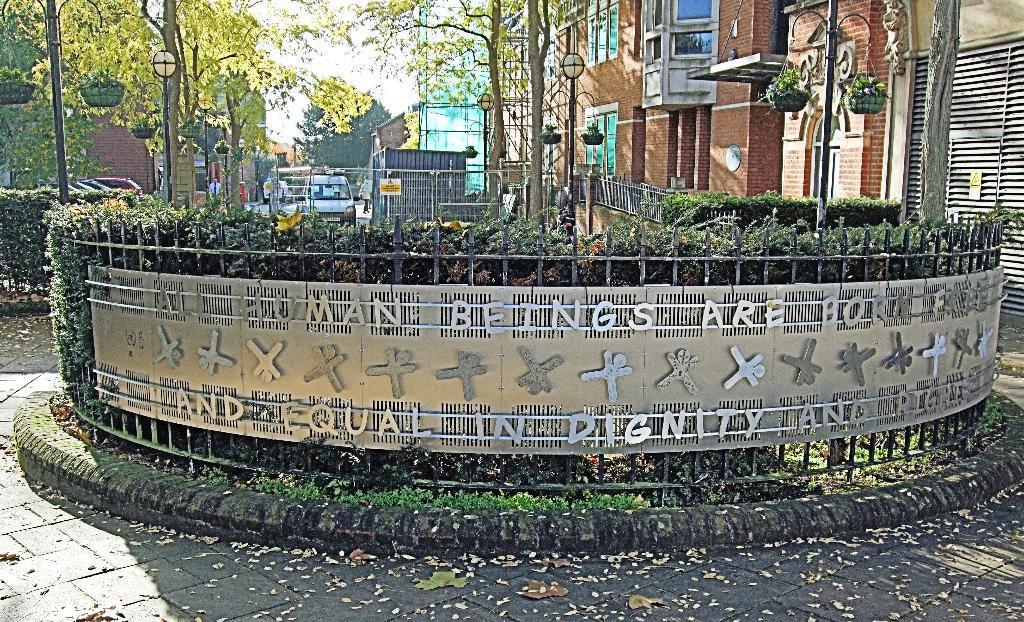Can you describe this image briefly? This picture is clicked outside. In the center we can see the metal fence and we can see the plants and we can see the text and sculptures attached to the fence. In the background we can see the trees, poles, vehicles and buildings and we can see the baskets hanging on the poles and we can see many other objects. 